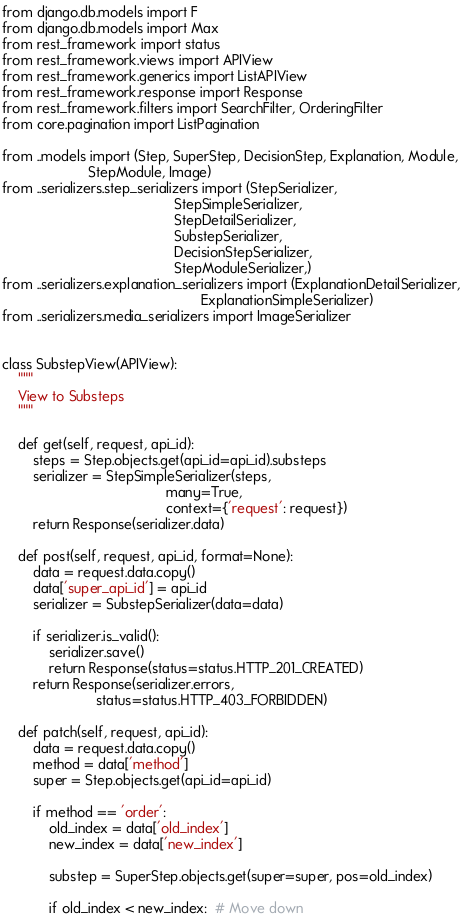Convert code to text. <code><loc_0><loc_0><loc_500><loc_500><_Python_>from django.db.models import F
from django.db.models import Max
from rest_framework import status
from rest_framework.views import APIView
from rest_framework.generics import ListAPIView
from rest_framework.response import Response
from rest_framework.filters import SearchFilter, OrderingFilter
from core.pagination import ListPagination

from ..models import (Step, SuperStep, DecisionStep, Explanation, Module,
                      StepModule, Image)
from ..serializers.step_serializers import (StepSerializer,
                                            StepSimpleSerializer,
                                            StepDetailSerializer,
                                            SubstepSerializer,
                                            DecisionStepSerializer,
                                            StepModuleSerializer,)
from ..serializers.explanation_serializers import (ExplanationDetailSerializer,
                                                   ExplanationSimpleSerializer)
from ..serializers.media_serializers import ImageSerializer


class SubstepView(APIView):
    """
    View to Substeps
    """

    def get(self, request, api_id):
        steps = Step.objects.get(api_id=api_id).substeps
        serializer = StepSimpleSerializer(steps,
                                          many=True,
                                          context={'request': request})
        return Response(serializer.data)

    def post(self, request, api_id, format=None):
        data = request.data.copy()
        data['super_api_id'] = api_id
        serializer = SubstepSerializer(data=data)

        if serializer.is_valid():
            serializer.save()
            return Response(status=status.HTTP_201_CREATED)
        return Response(serializer.errors,
                        status=status.HTTP_403_FORBIDDEN)

    def patch(self, request, api_id):
        data = request.data.copy()
        method = data['method']
        super = Step.objects.get(api_id=api_id)

        if method == 'order':
            old_index = data['old_index']
            new_index = data['new_index']

            substep = SuperStep.objects.get(super=super, pos=old_index)

            if old_index < new_index:  # Move down</code> 